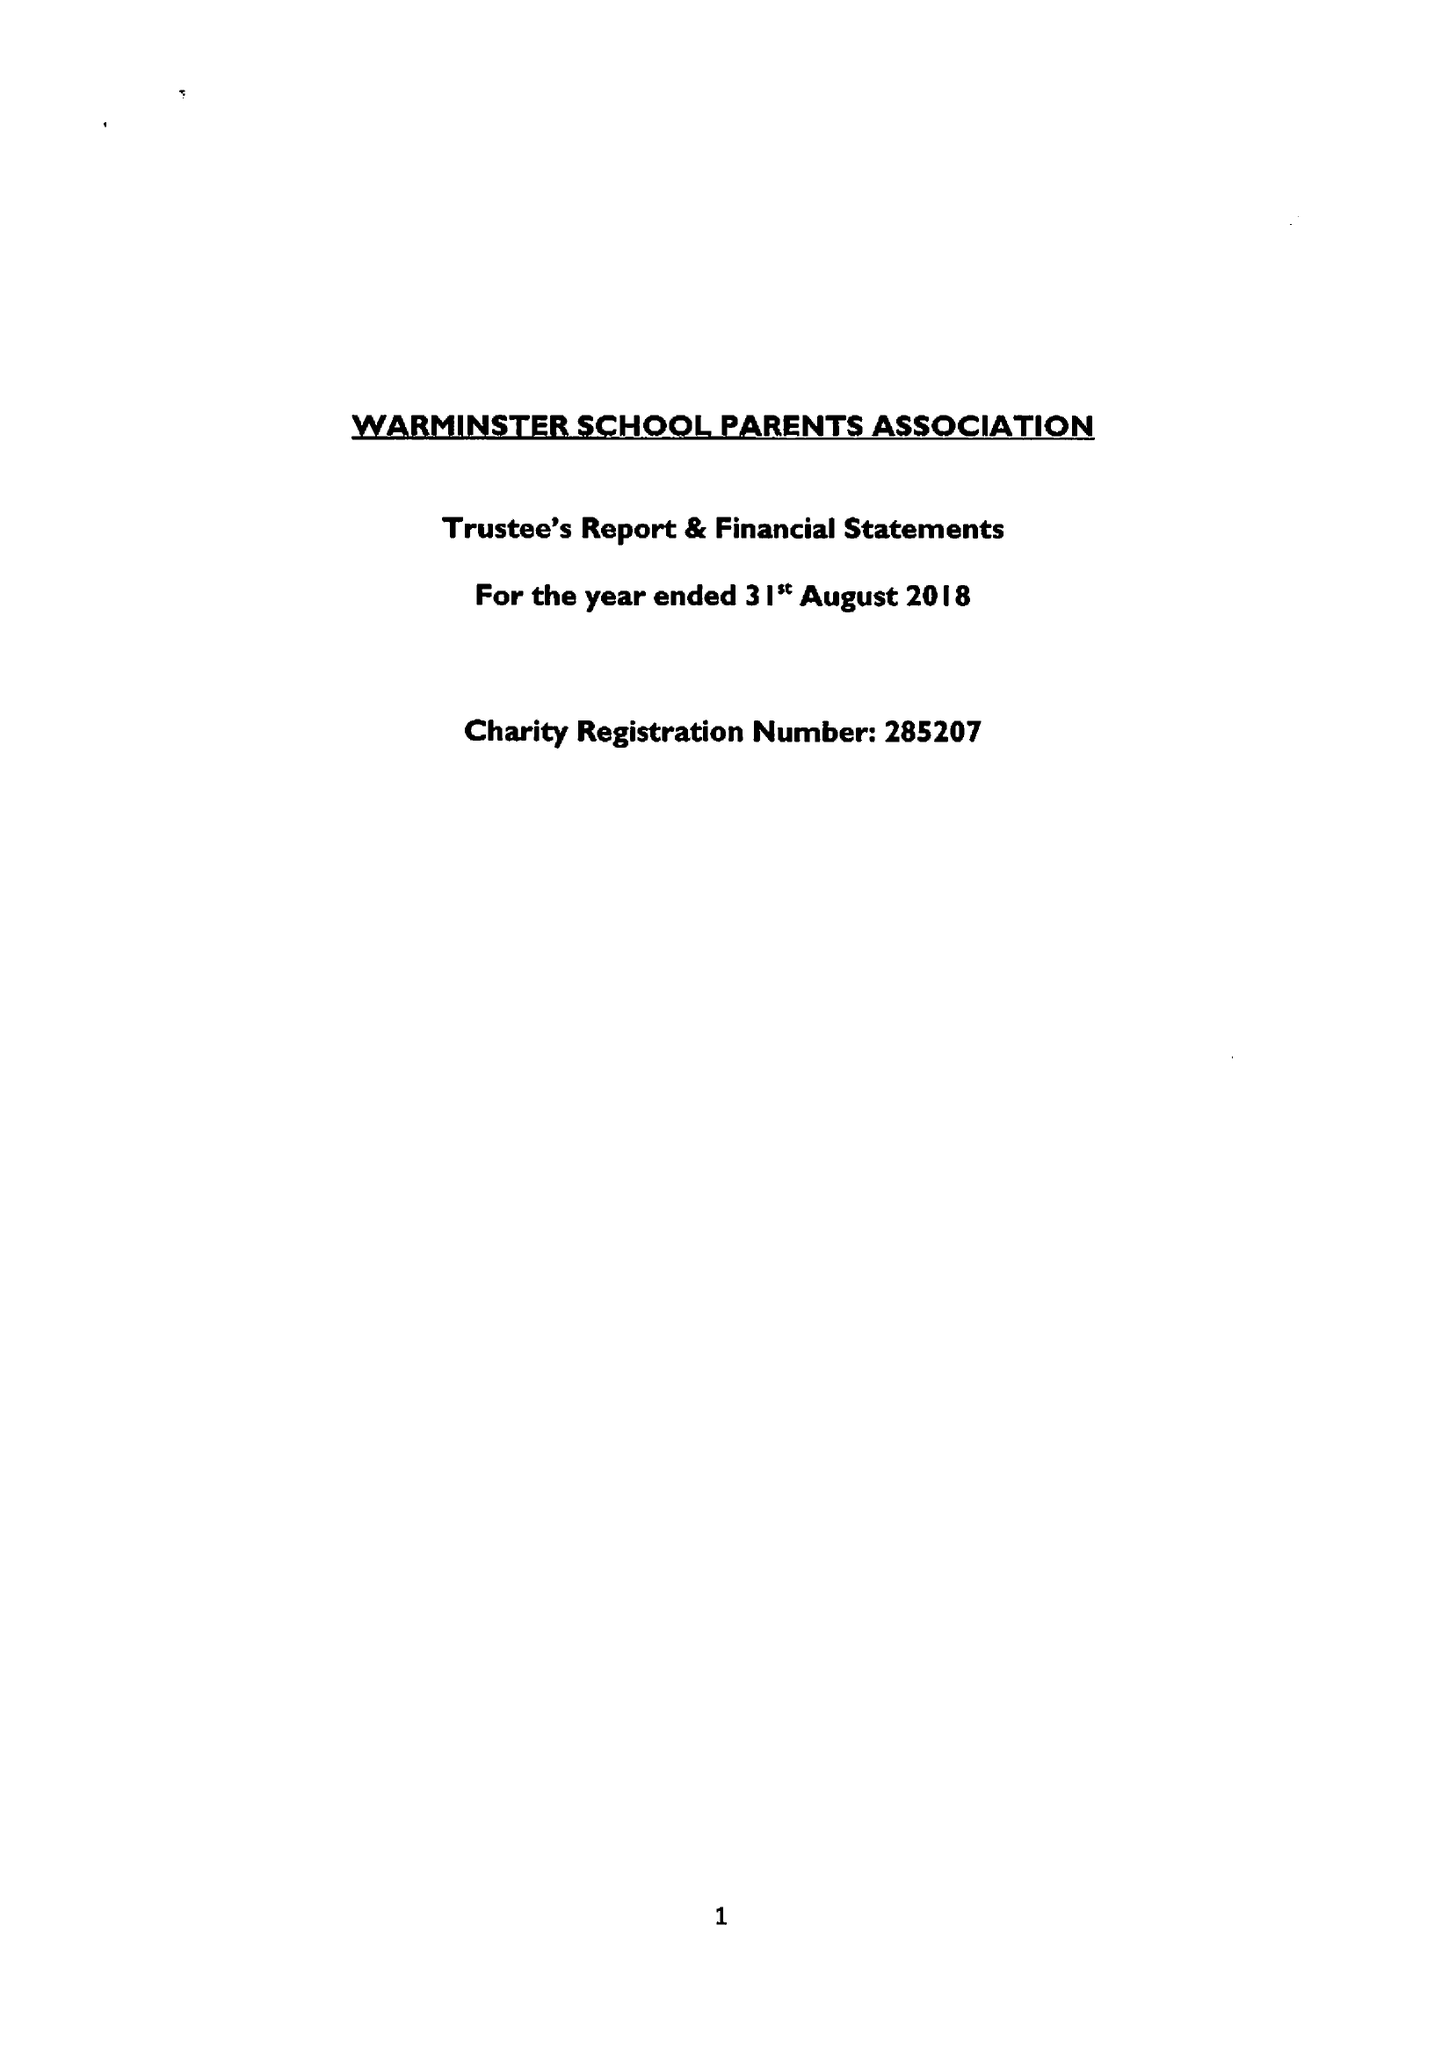What is the value for the charity_name?
Answer the question using a single word or phrase. Warminster School Parents' Association 